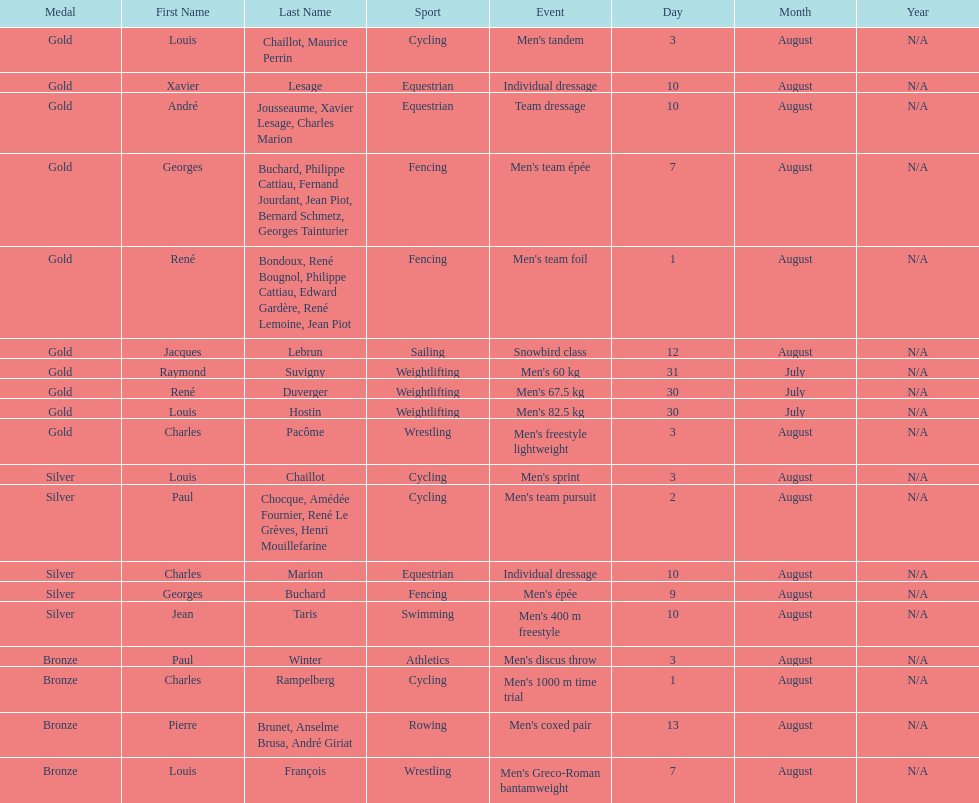How many total gold medals were won by weightlifting? 3. 